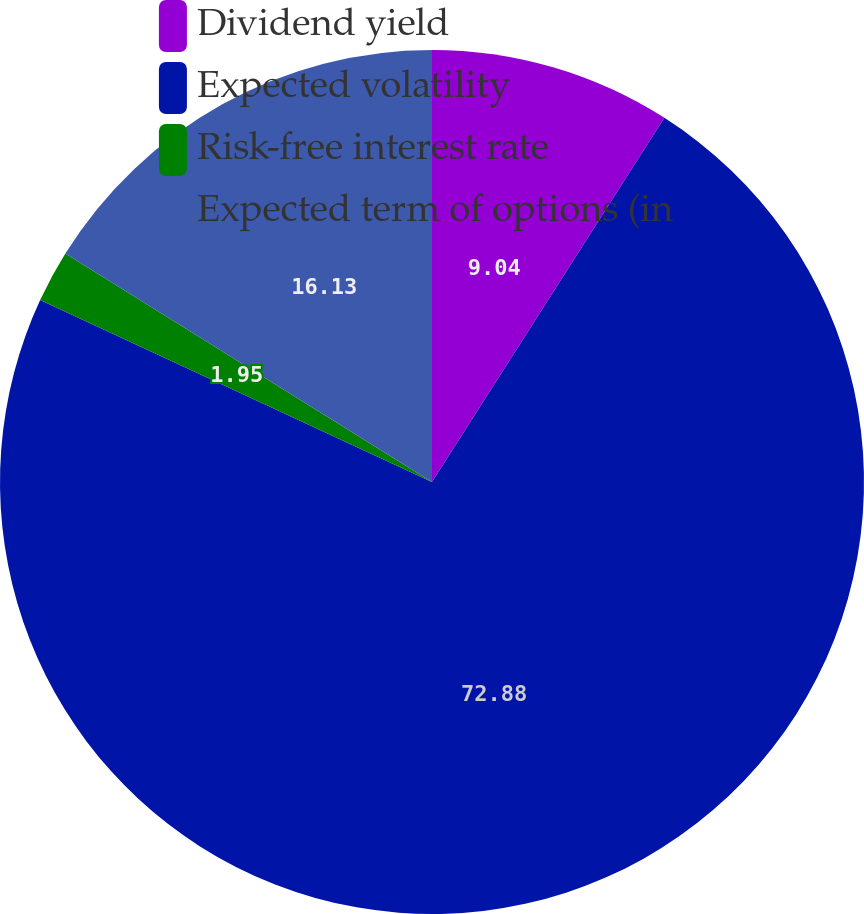Convert chart. <chart><loc_0><loc_0><loc_500><loc_500><pie_chart><fcel>Dividend yield<fcel>Expected volatility<fcel>Risk-free interest rate<fcel>Expected term of options (in<nl><fcel>9.04%<fcel>72.87%<fcel>1.95%<fcel>16.13%<nl></chart> 